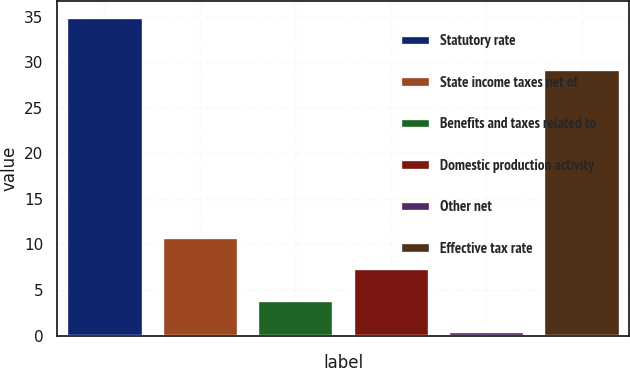Convert chart to OTSL. <chart><loc_0><loc_0><loc_500><loc_500><bar_chart><fcel>Statutory rate<fcel>State income taxes net of<fcel>Benefits and taxes related to<fcel>Domestic production activity<fcel>Other net<fcel>Effective tax rate<nl><fcel>35<fcel>10.85<fcel>3.95<fcel>7.4<fcel>0.5<fcel>29.3<nl></chart> 